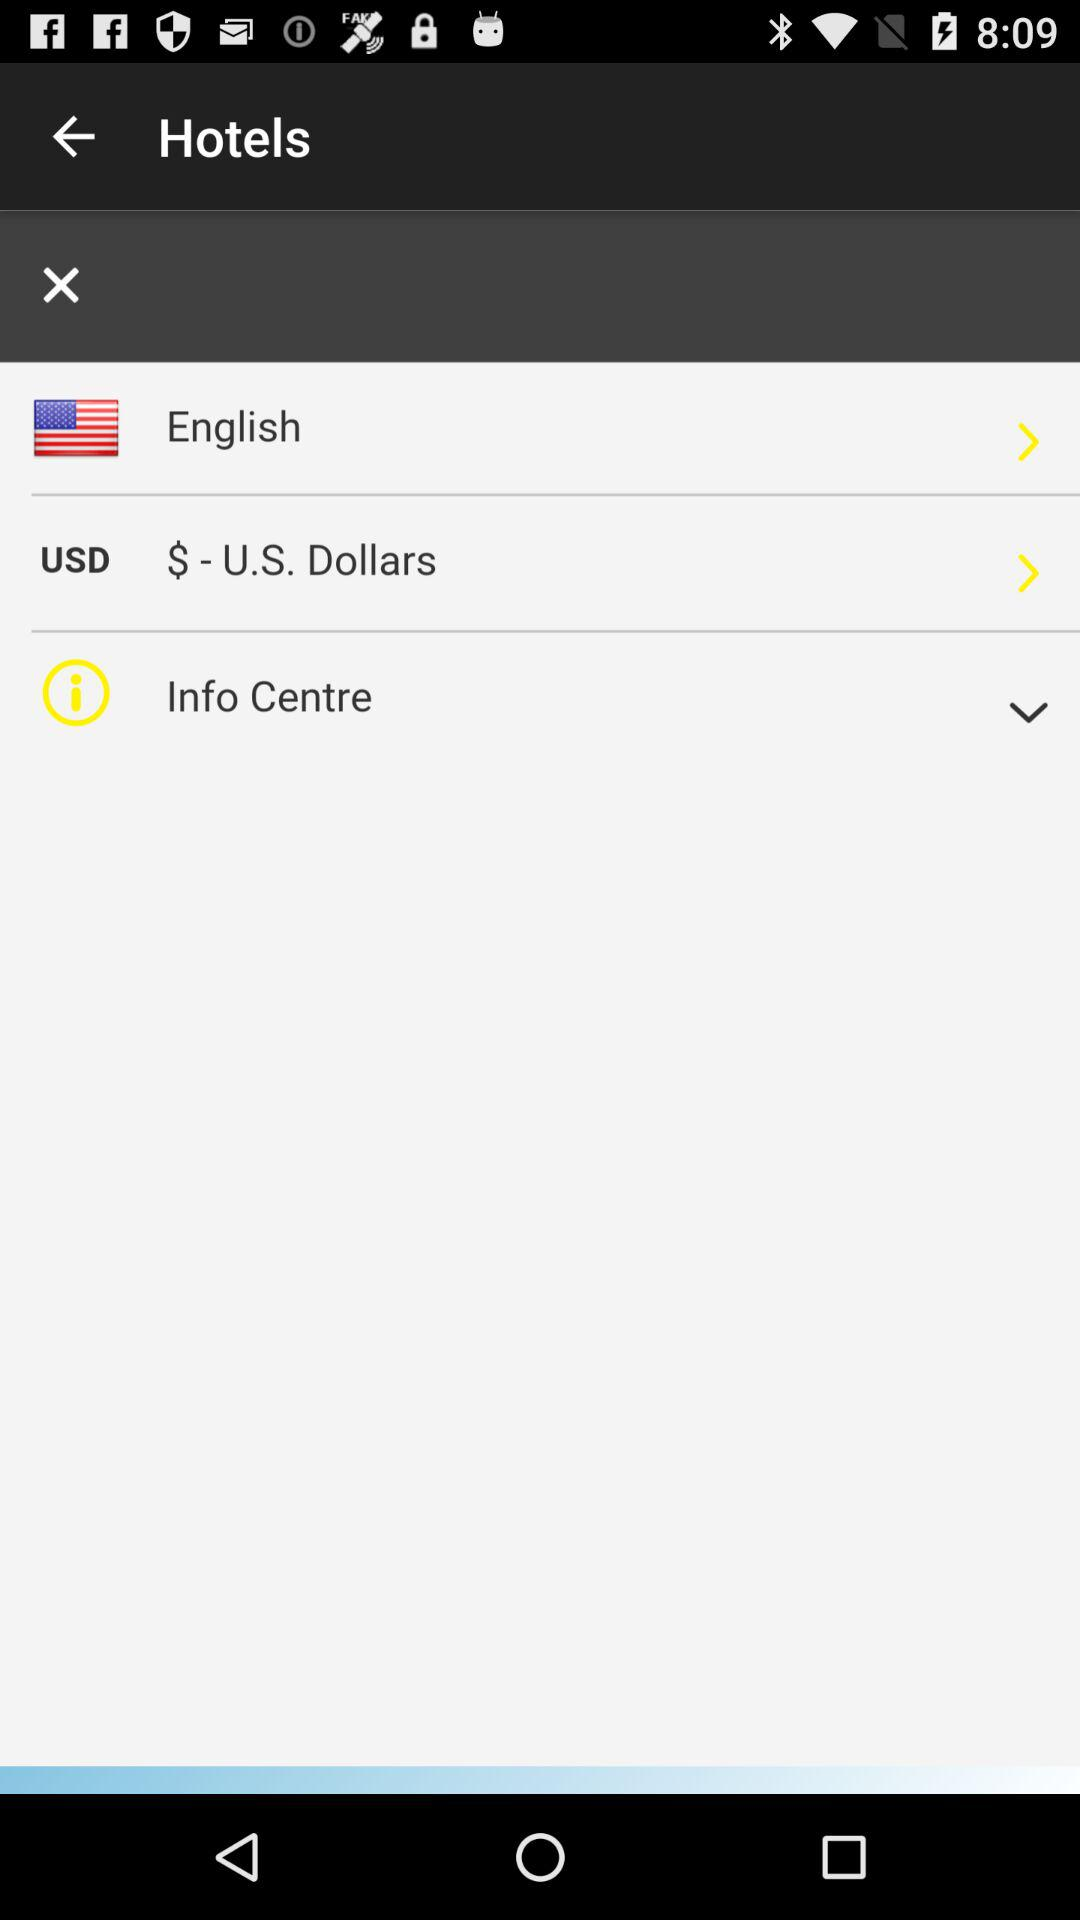Which is the language? The language is English. 